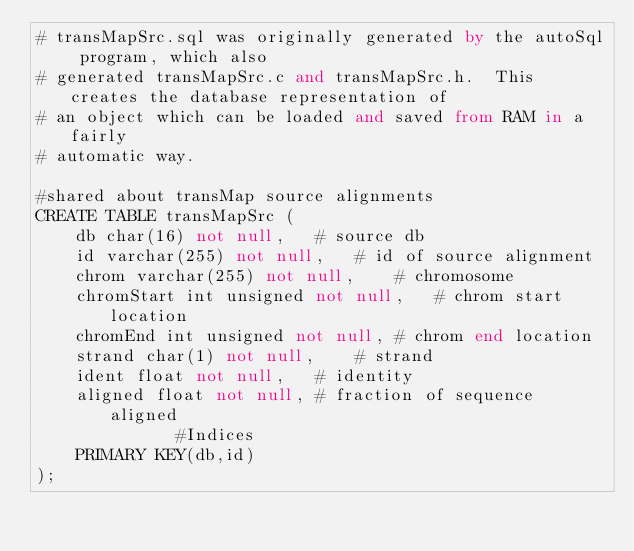<code> <loc_0><loc_0><loc_500><loc_500><_SQL_># transMapSrc.sql was originally generated by the autoSql program, which also 
# generated transMapSrc.c and transMapSrc.h.  This creates the database representation of
# an object which can be loaded and saved from RAM in a fairly 
# automatic way.

#shared about transMap source alignments
CREATE TABLE transMapSrc (
    db char(16) not null,	# source db
    id varchar(255) not null,	# id of source alignment
    chrom varchar(255) not null,	# chromosome
    chromStart int unsigned not null,	# chrom start location
    chromEnd int unsigned not null,	# chrom end location
    strand char(1) not null,	# strand
    ident float not null,	# identity
    aligned float not null,	# fraction of sequence aligned
              #Indices
    PRIMARY KEY(db,id)
);
</code> 